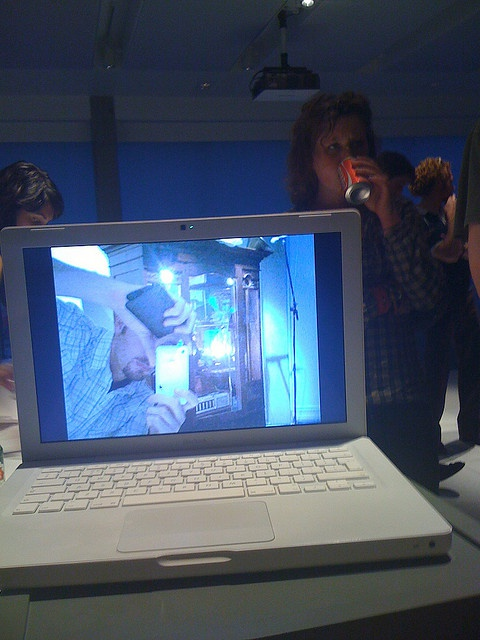Describe the objects in this image and their specific colors. I can see laptop in black, darkgray, gray, lightblue, and navy tones, people in black, maroon, navy, and gray tones, people in black, maroon, navy, and gray tones, people in black, navy, gray, and purple tones, and cell phone in black, white, cyan, and lightblue tones in this image. 